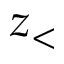<formula> <loc_0><loc_0><loc_500><loc_500>z _ { < }</formula> 